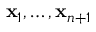Convert formula to latex. <formula><loc_0><loc_0><loc_500><loc_500>x _ { 1 } , \dots , x _ { n + 1 }</formula> 